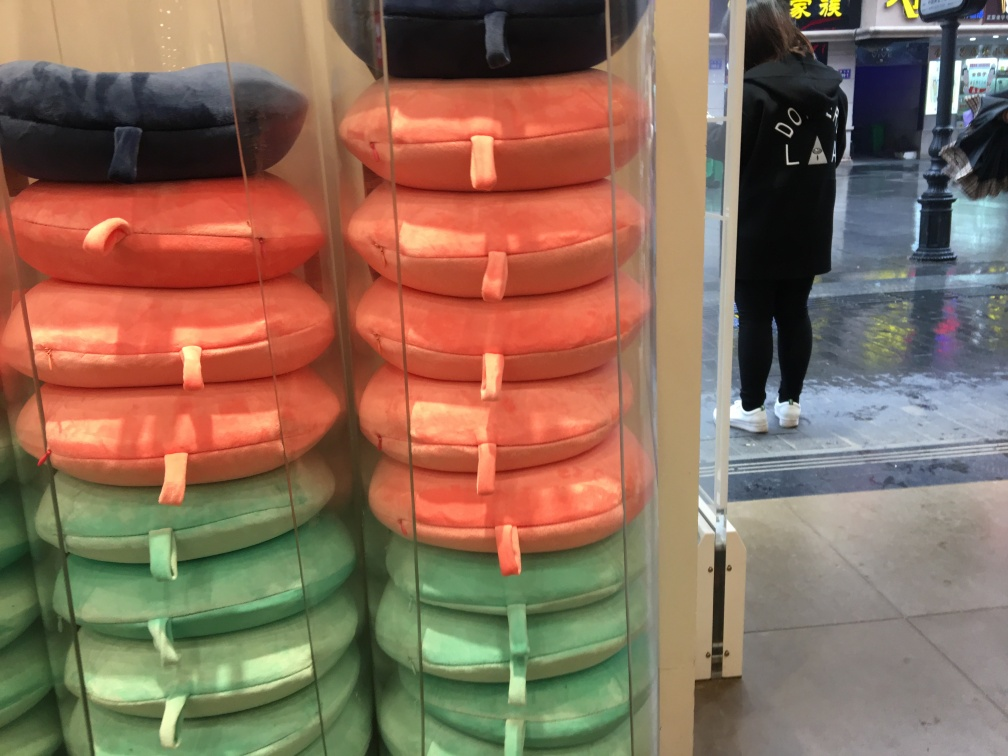I am curious about the reflection in the glass. What can we learn about the place and time? The reflection in the glass reveals a wet, reflective ground outside that implies recent rain. A person is seen walking by, wearing a casual outfit with a jacket, which could suggest cooler weather. The lighting in the reflection appears to be that of daytime, and buildings and lampposts indicate an urban street scene. 